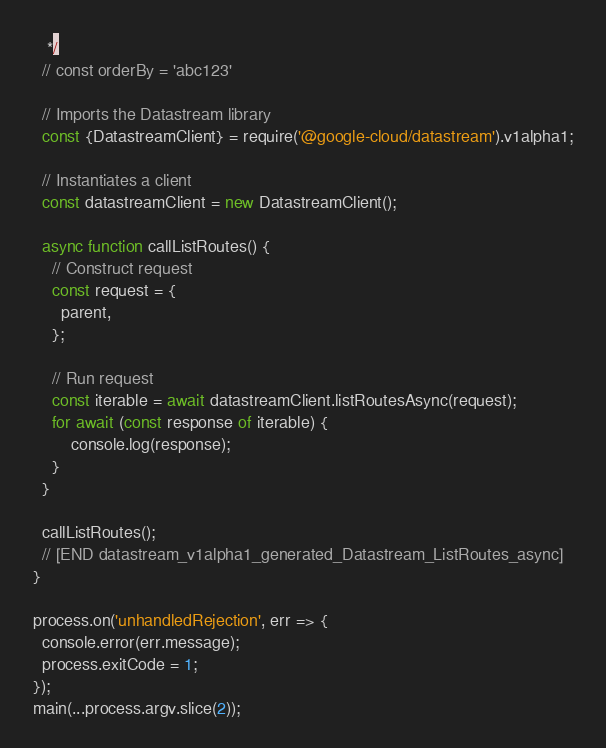<code> <loc_0><loc_0><loc_500><loc_500><_JavaScript_>   */
  // const orderBy = 'abc123'

  // Imports the Datastream library
  const {DatastreamClient} = require('@google-cloud/datastream').v1alpha1;

  // Instantiates a client
  const datastreamClient = new DatastreamClient();

  async function callListRoutes() {
    // Construct request
    const request = {
      parent,
    };

    // Run request
    const iterable = await datastreamClient.listRoutesAsync(request);
    for await (const response of iterable) {
        console.log(response);
    }
  }

  callListRoutes();
  // [END datastream_v1alpha1_generated_Datastream_ListRoutes_async]
}

process.on('unhandledRejection', err => {
  console.error(err.message);
  process.exitCode = 1;
});
main(...process.argv.slice(2));
</code> 